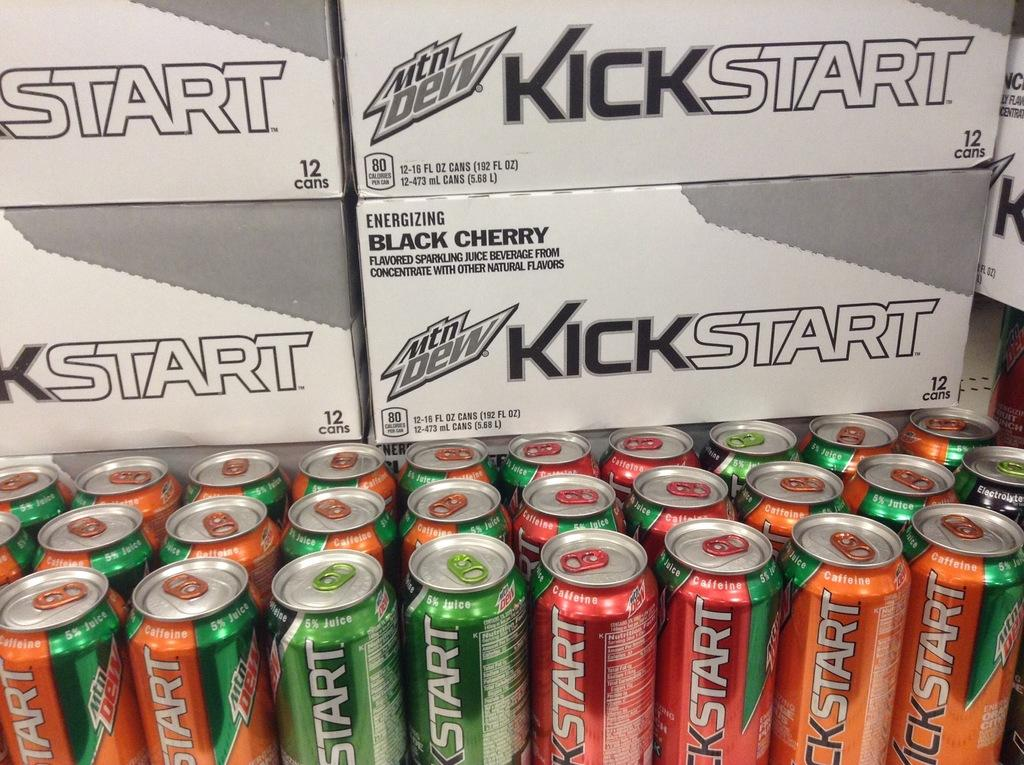<image>
Write a terse but informative summary of the picture. Cans of kickstart are arranged in front of boxes of kickstart. 